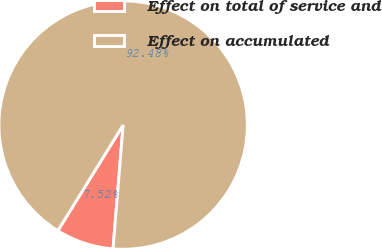Convert chart to OTSL. <chart><loc_0><loc_0><loc_500><loc_500><pie_chart><fcel>Effect on total of service and<fcel>Effect on accumulated<nl><fcel>7.52%<fcel>92.48%<nl></chart> 